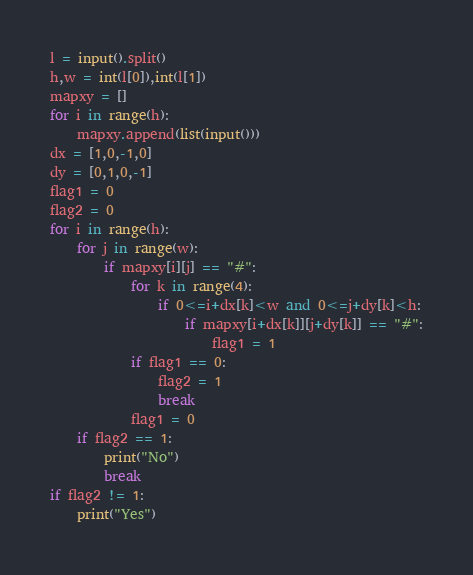Convert code to text. <code><loc_0><loc_0><loc_500><loc_500><_Python_>l = input().split()
h,w = int(l[0]),int(l[1])
mapxy = []
for i in range(h):
    mapxy.append(list(input()))
dx = [1,0,-1,0]
dy = [0,1,0,-1]
flag1 = 0
flag2 = 0
for i in range(h):
    for j in range(w):
        if mapxy[i][j] == "#":
            for k in range(4):
                if 0<=i+dx[k]<w and 0<=j+dy[k]<h:
                    if mapxy[i+dx[k]][j+dy[k]] == "#":
                        flag1 = 1
            if flag1 == 0:
                flag2 = 1
                break
            flag1 = 0
    if flag2 == 1:
        print("No")
        break
if flag2 != 1:
    print("Yes")</code> 